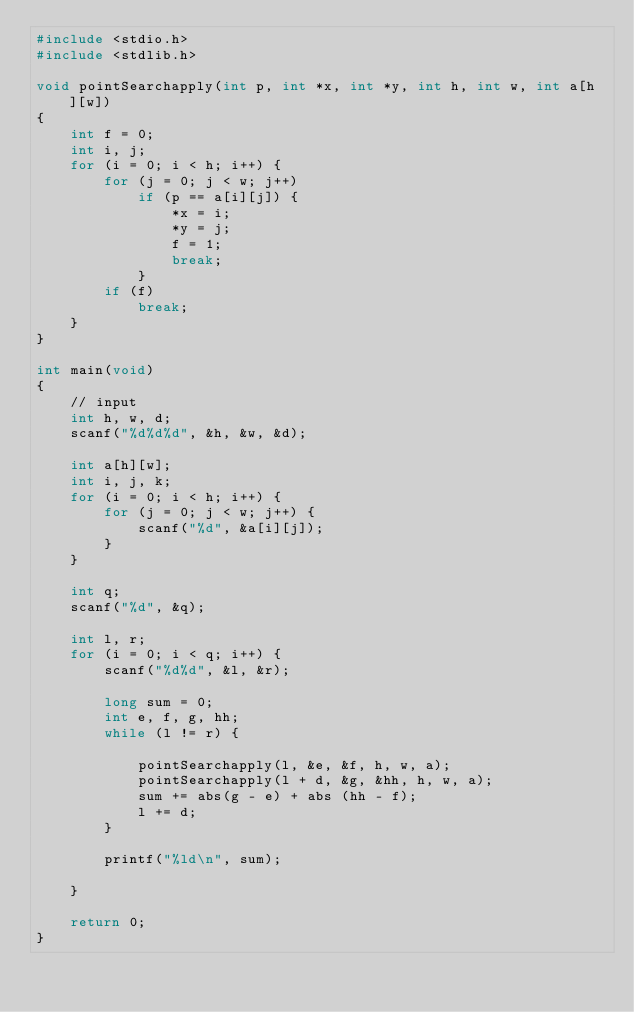<code> <loc_0><loc_0><loc_500><loc_500><_C_>#include <stdio.h>
#include <stdlib.h>

void pointSearchapply(int p, int *x, int *y, int h, int w, int a[h][w])
{
    int f = 0;
    int i, j;
    for (i = 0; i < h; i++) {
        for (j = 0; j < w; j++)
            if (p == a[i][j]) {
                *x = i;
                *y = j;
                f = 1;
                break;
            }
        if (f)
            break;
    }
}

int main(void)
{
    // input
    int h, w, d;
    scanf("%d%d%d", &h, &w, &d);

    int a[h][w];
    int i, j, k;
    for (i = 0; i < h; i++) {
        for (j = 0; j < w; j++) {
            scanf("%d", &a[i][j]);
        }
    }

    int q;
    scanf("%d", &q);

    int l, r;
    for (i = 0; i < q; i++) {
        scanf("%d%d", &l, &r);
        
        long sum = 0;
        int e, f, g, hh;
        while (l != r) {
            
            pointSearchapply(l, &e, &f, h, w, a);
            pointSearchapply(l + d, &g, &hh, h, w, a);
            sum += abs(g - e) + abs (hh - f);
            l += d;
        }

        printf("%ld\n", sum);
        
    }
    
    return 0;
}</code> 